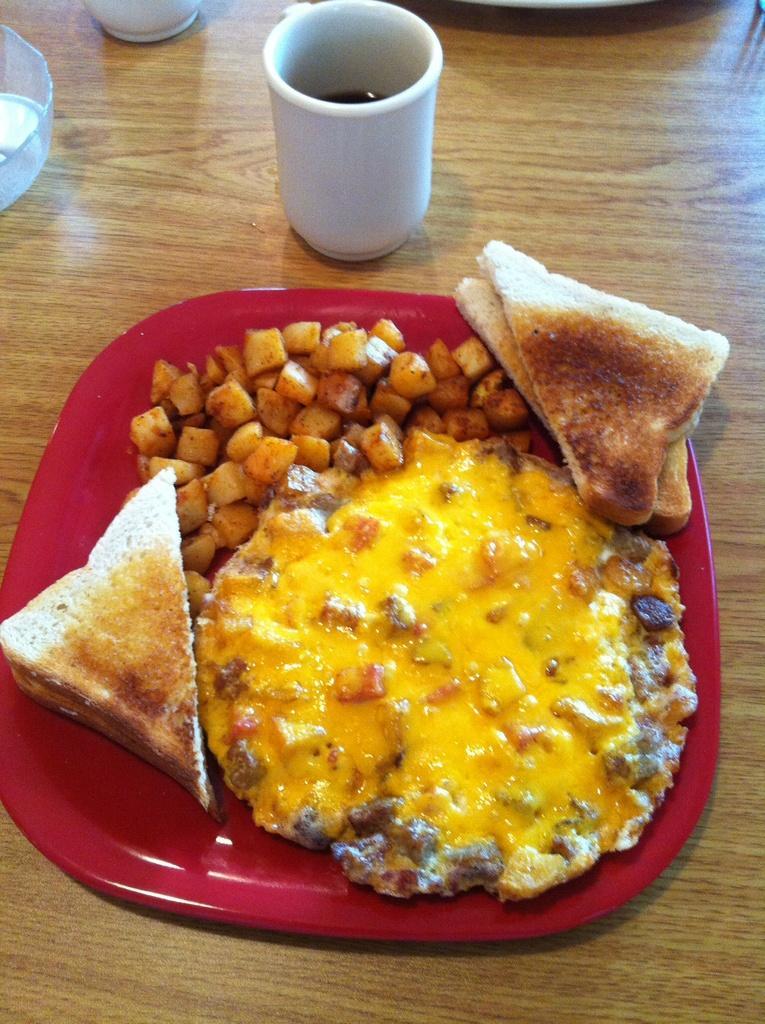Could you give a brief overview of what you see in this image? There is a wooden table. On that there is a white cup and a red plate. On the plate there are toasted breads, fried potato pieces and yellow color food item. 